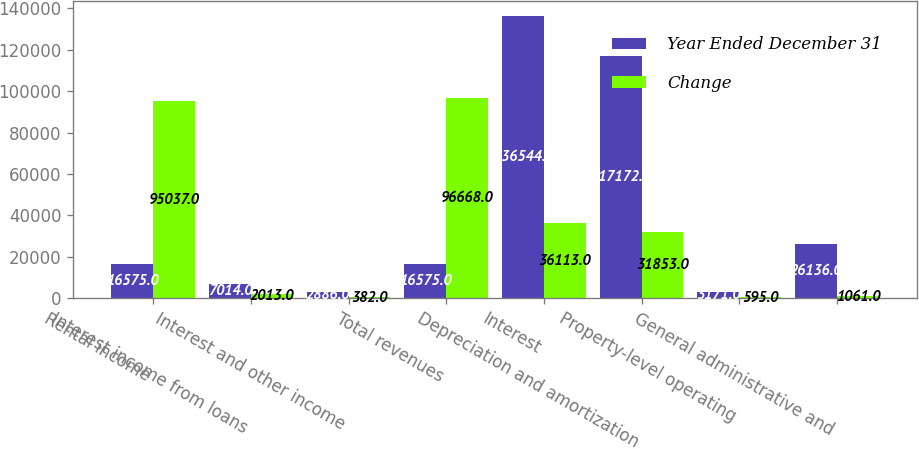Convert chart. <chart><loc_0><loc_0><loc_500><loc_500><stacked_bar_chart><ecel><fcel>Rental income<fcel>Interest income from loans<fcel>Interest and other income<fcel>Total revenues<fcel>Interest<fcel>Depreciation and amortization<fcel>Property-level operating<fcel>General administrative and<nl><fcel>Year Ended December 31<fcel>16575<fcel>7014<fcel>2886<fcel>16575<fcel>136544<fcel>117172<fcel>3171<fcel>26136<nl><fcel>Change<fcel>95037<fcel>2013<fcel>382<fcel>96668<fcel>36113<fcel>31853<fcel>595<fcel>1061<nl></chart> 